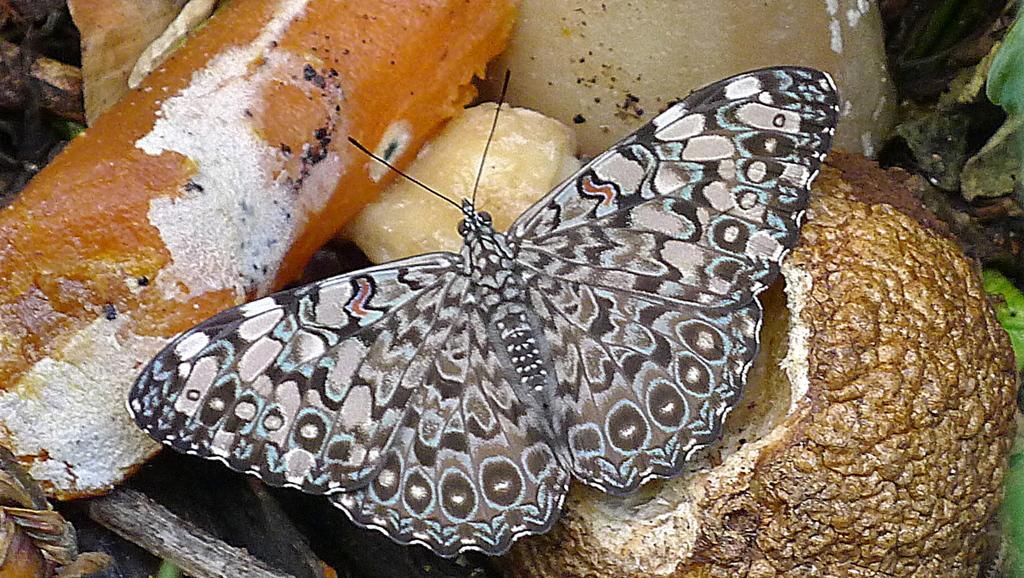In one or two sentences, can you explain what this image depicts? In this image we can see a butterfly and food items. 